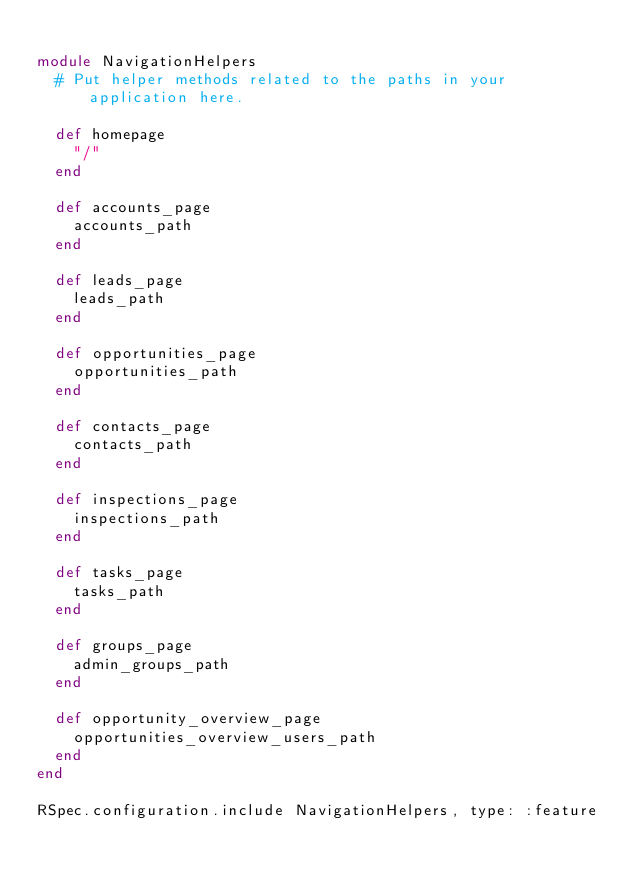<code> <loc_0><loc_0><loc_500><loc_500><_Ruby_>
module NavigationHelpers
  # Put helper methods related to the paths in your application here.

  def homepage
    "/"
  end

  def accounts_page
    accounts_path
  end

  def leads_page
    leads_path
  end

  def opportunities_page
    opportunities_path
  end

  def contacts_page
    contacts_path
  end

  def inspections_page
    inspections_path
  end

  def tasks_page
    tasks_path
  end

  def groups_page
    admin_groups_path
  end

  def opportunity_overview_page
    opportunities_overview_users_path
  end
end

RSpec.configuration.include NavigationHelpers, type: :feature
</code> 